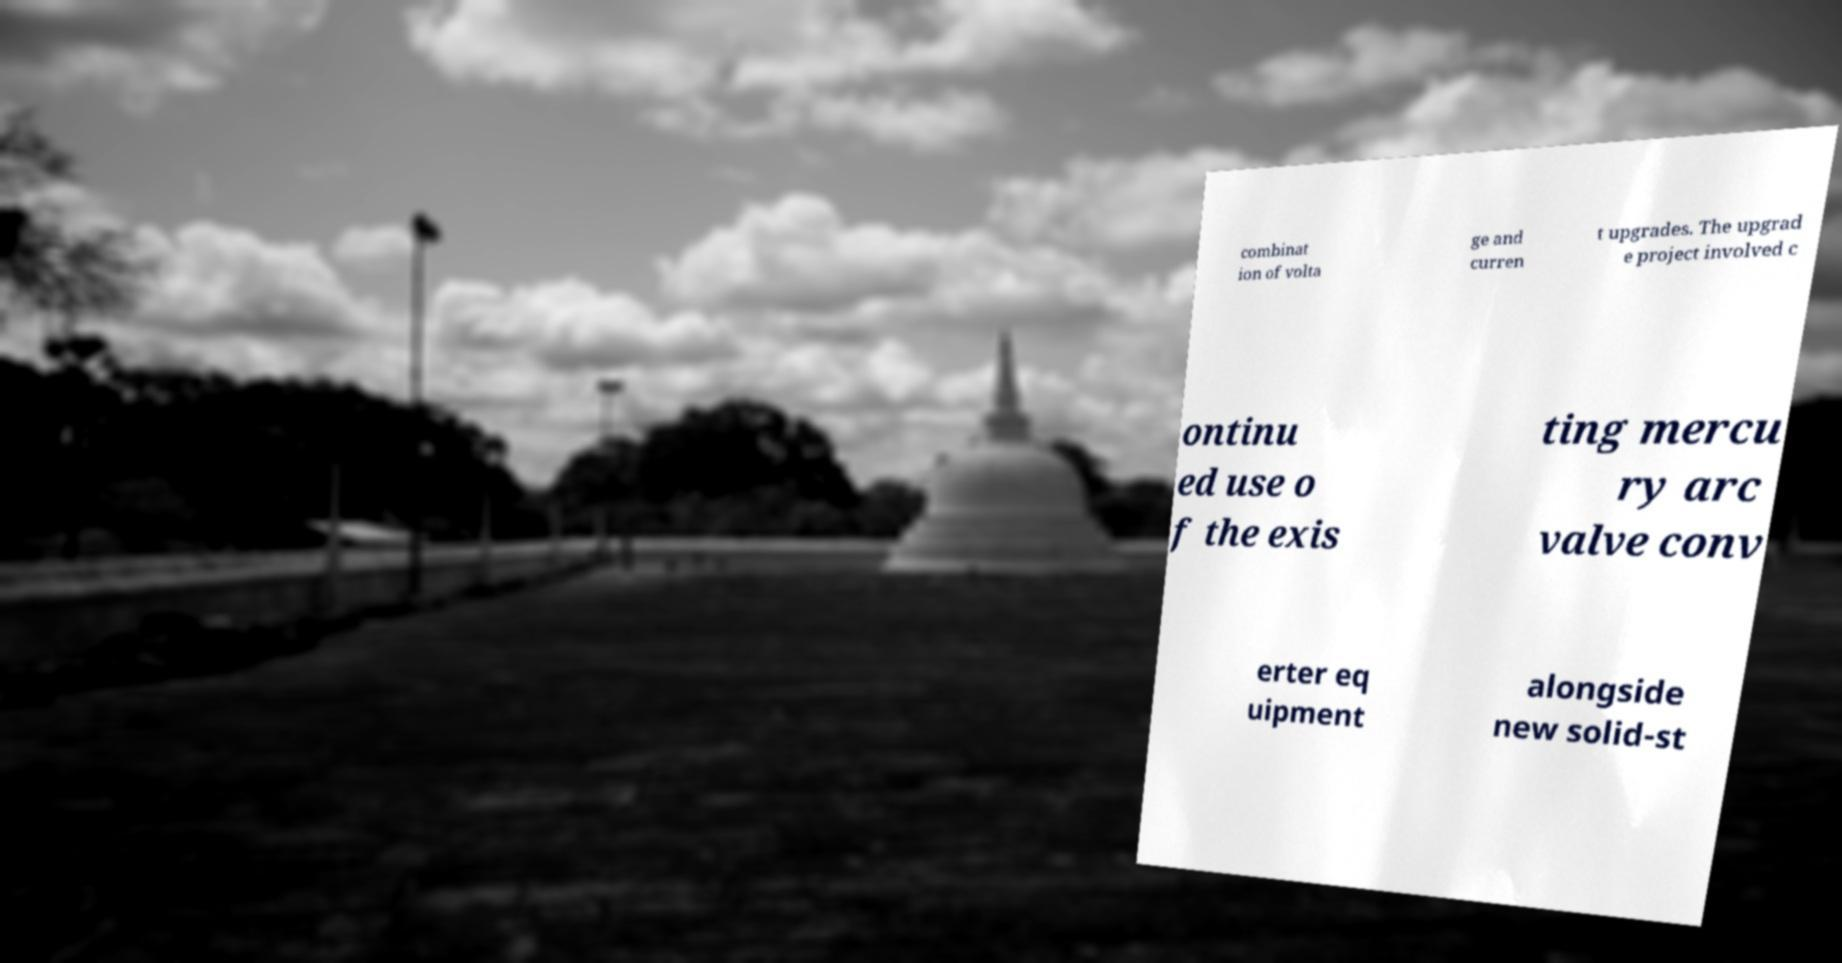Could you extract and type out the text from this image? combinat ion of volta ge and curren t upgrades. The upgrad e project involved c ontinu ed use o f the exis ting mercu ry arc valve conv erter eq uipment alongside new solid-st 